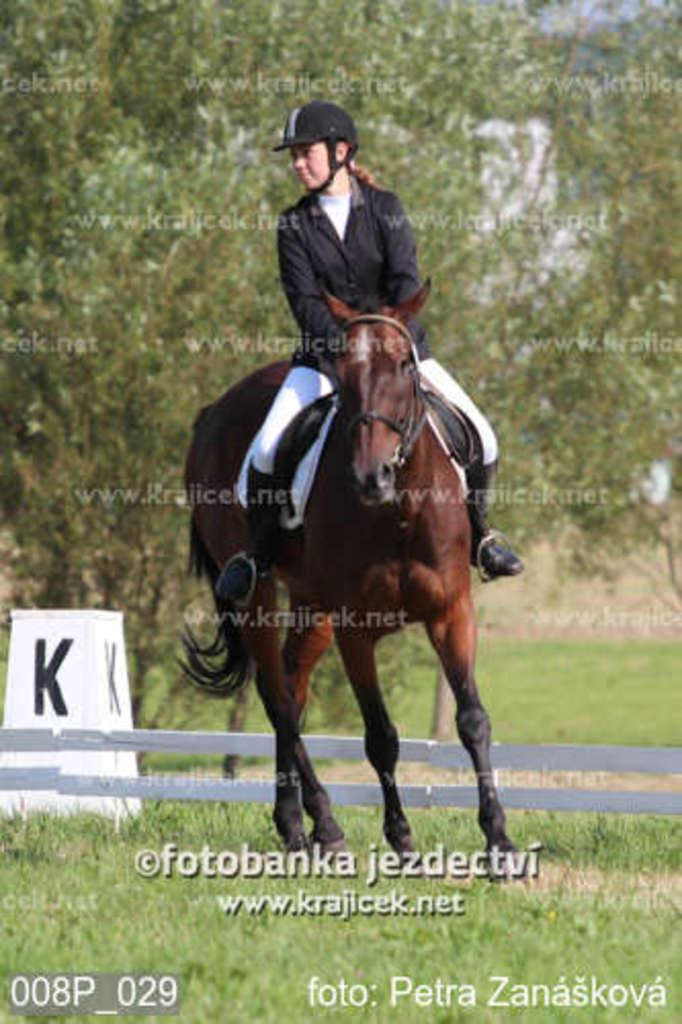What animal is present in the image? There is a horse in the image. What is the horse doing in the image? The horse is running on the grass. Is there anyone riding the horse? Yes, there is a person sitting on the horse. What can be seen in the background of the image? There is a board, wooden planks, and trees in the background of the image. Is there any text present in the image? Yes, there is some text in the image. What type of cemetery can be seen in the background of the image? There is no cemetery present in the image; it features a horse running on the grass with a person riding it, along with a background that includes a board, wooden planks, and trees. 